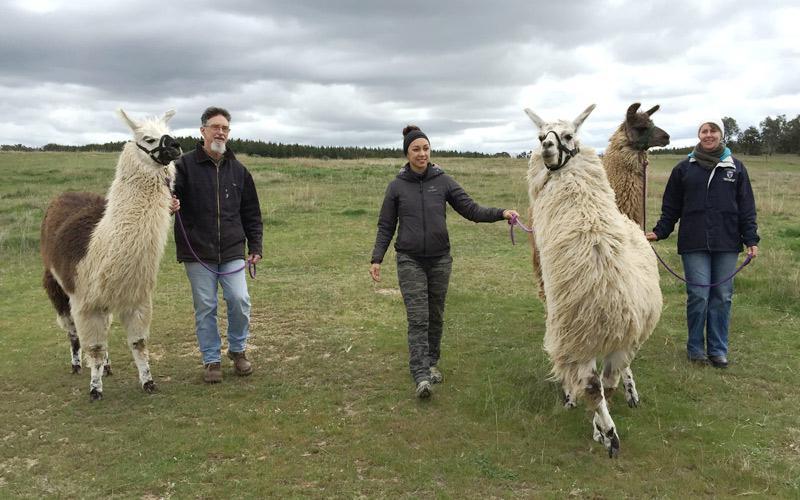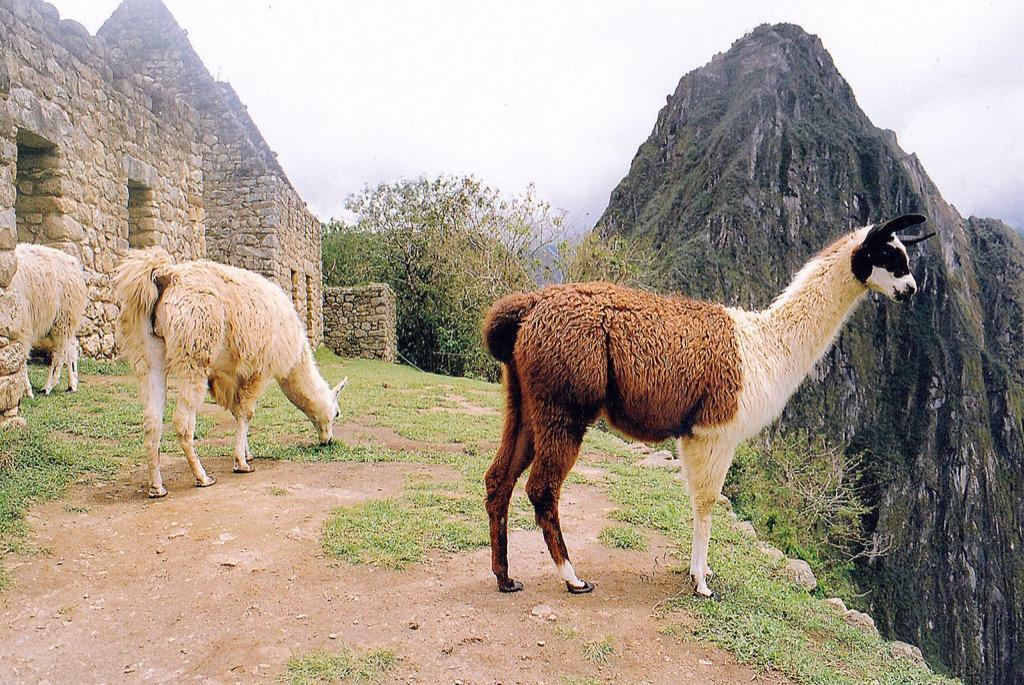The first image is the image on the left, the second image is the image on the right. Analyze the images presented: Is the assertion "There are exactly six llamas in total." valid? Answer yes or no. Yes. The first image is the image on the left, the second image is the image on the right. Considering the images on both sides, is "The left image contains no more than one person interacting with a llama." valid? Answer yes or no. No. 